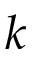<formula> <loc_0><loc_0><loc_500><loc_500>k</formula> 